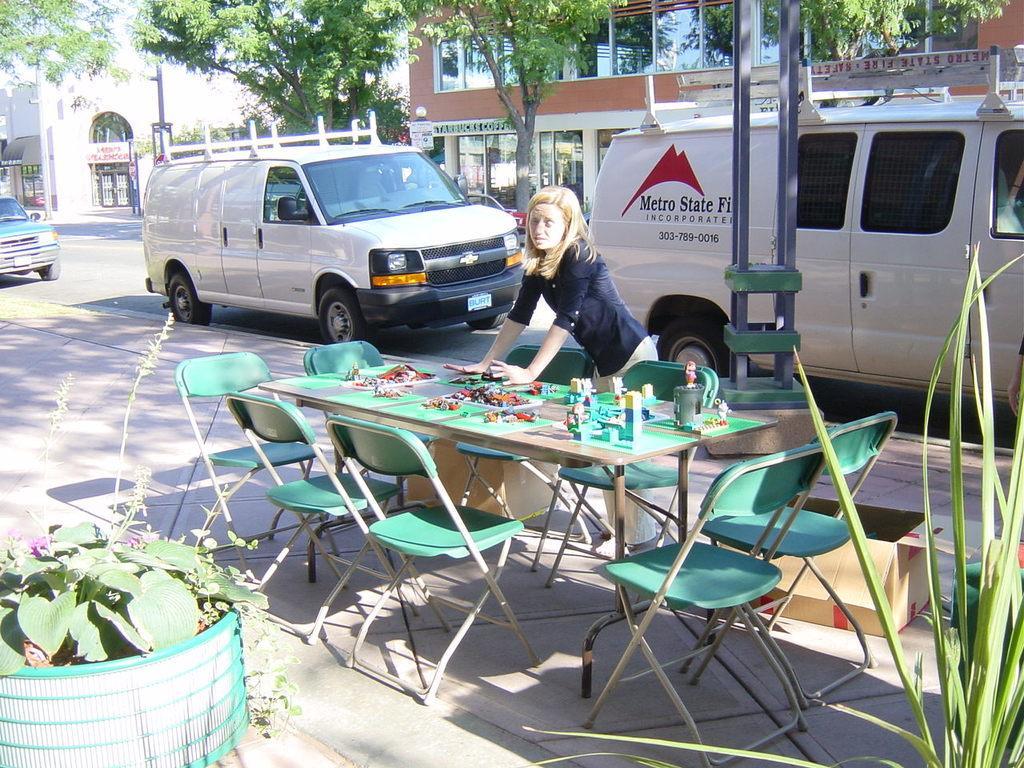In one or two sentences, can you explain what this image depicts? In this picture we can see a lady who is standing near a table and some chairs around the table and on the table we have some things and beside her there is street on which there are some cars and plants. 